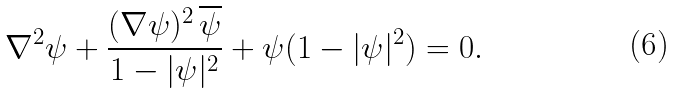<formula> <loc_0><loc_0><loc_500><loc_500>\nabla ^ { 2 } \psi + \frac { ( \nabla \psi ) ^ { 2 } \, \overline { \psi } } { 1 - | \psi | ^ { 2 } } + \psi ( 1 - | \psi | ^ { 2 } ) = 0 .</formula> 